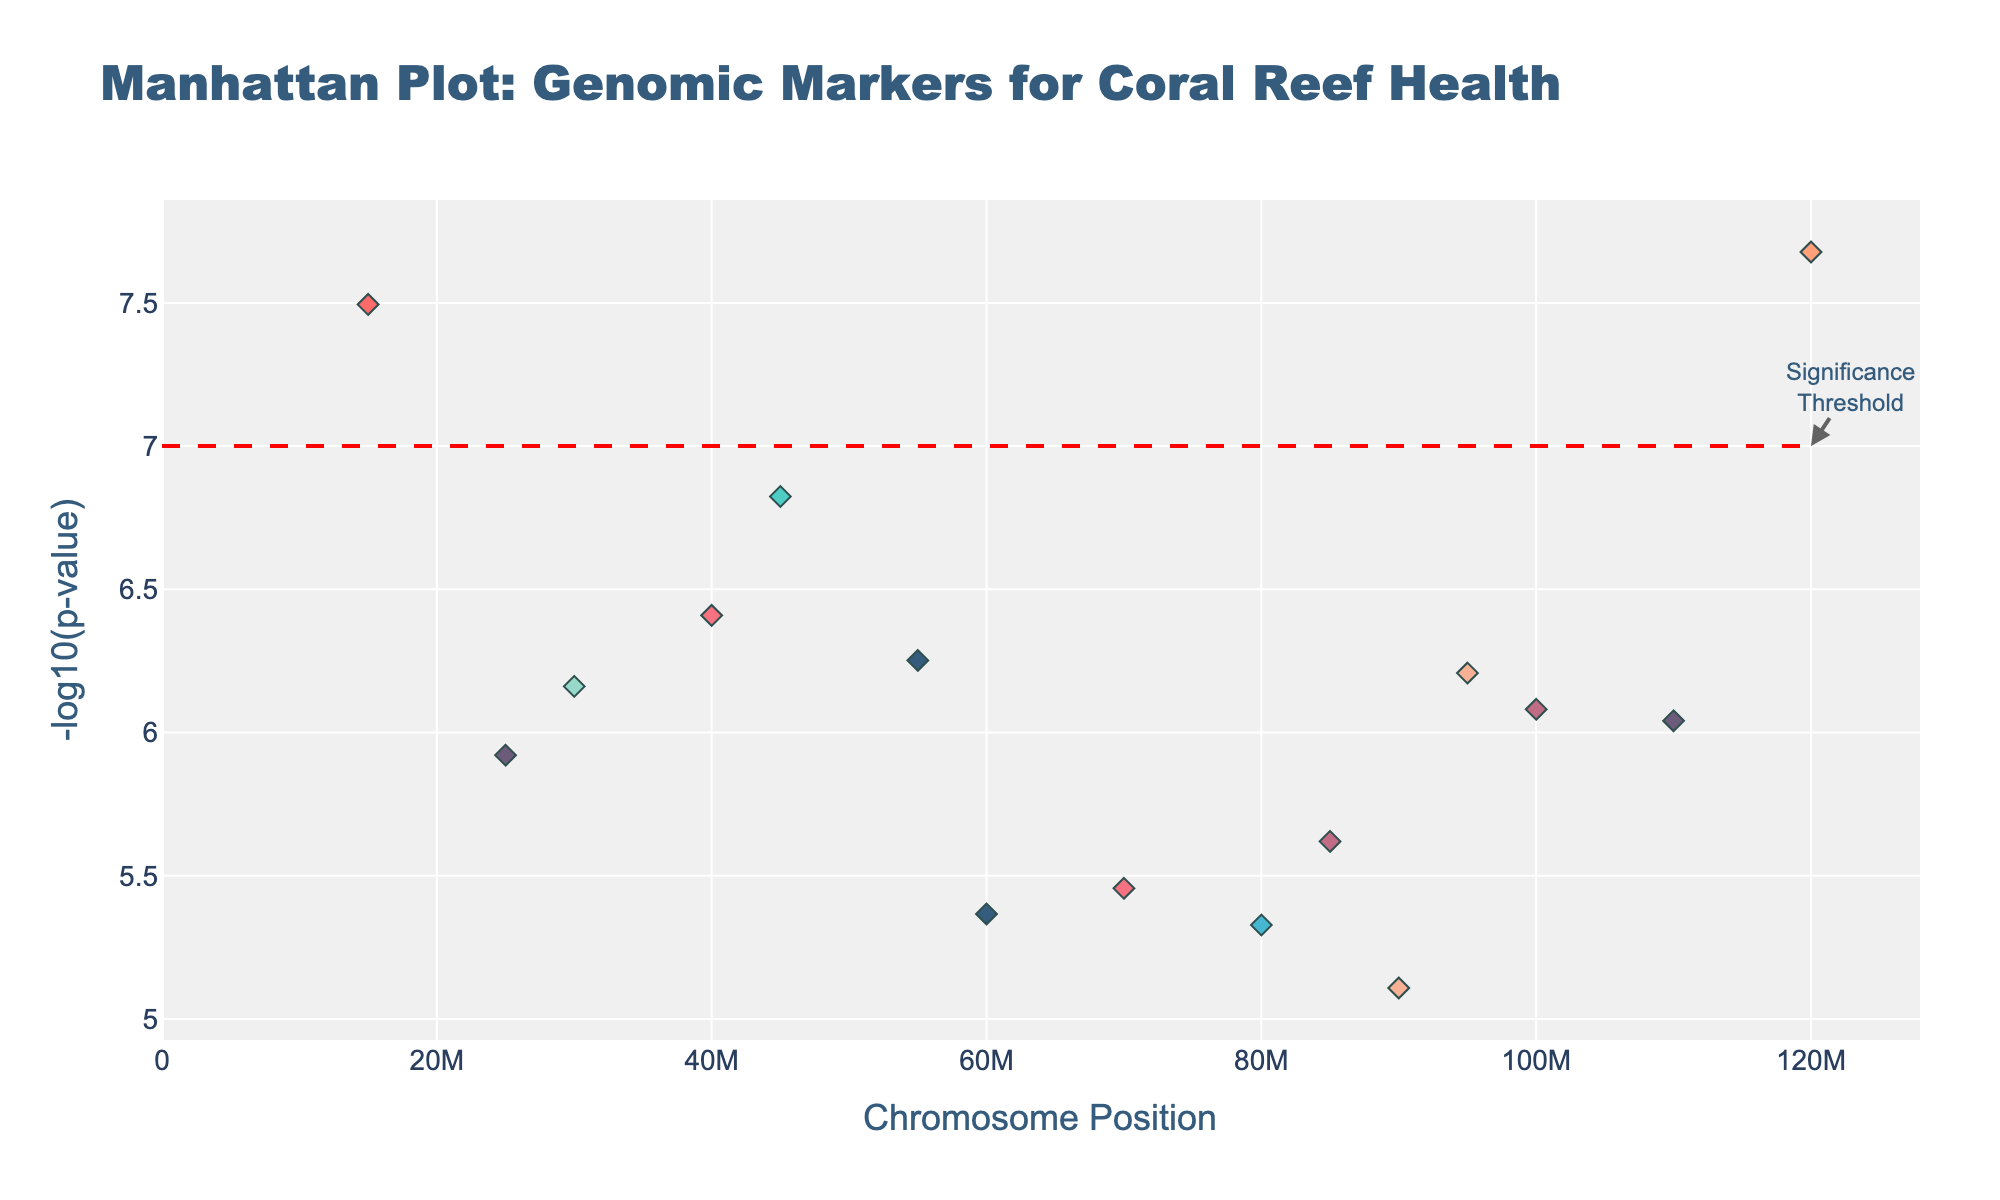What is the title of the plot? The title of the plot can be found directly at the top of the figure.
Answer: Manhattan Plot: Genomic Markers for Coral Reef Health What does the y-axis represent? The y-axis label is directly provided in the figure.
Answer: -log10(p-value) Which chromosome has the most significant genomic marker? Look for the chromosome with the data point that has the highest -log10(p-value).
Answer: Chromosome 1 What is the significance threshold for the p-value? The threshold line is marked by a horizontal line and labeled as "Significance Threshold" on the plot.
Answer: 7 How many chromosomes have data points that exceed the significance threshold? Count the number of chromosomes that have at least one data point above the horizontal line at -log10(p-value) = 7.
Answer: 6 Which gene is located at approximately position 15000000 on chromosome 1? Hover over the points or refer to the chromosome and position coordinates.
Answer: ACROPORA1 Which trait is associated with the gene that has the lowest p-value? Find the data point with the highest -log10(p-value) and check its associated trait in the hover text.
Answer: Thermal tolerance Is there a data point on chromosome 4 that exceeds the significance threshold? Check the height of the points on chromosome 4 relative to the significance threshold line.
Answer: Yes Does chromosome 10 have any significant genomic markers? Look at the points on chromosome 10 and see if any of them are above the threshold line at -log10(p-value) = 7.
Answer: No Which two chromosomes have the most similar highest -log10(p-value) values? Compare the highest -log10(p-value) values for each chromosome and identify the closest pair.
Answer: Chromosome 5 and Chromosome 9 